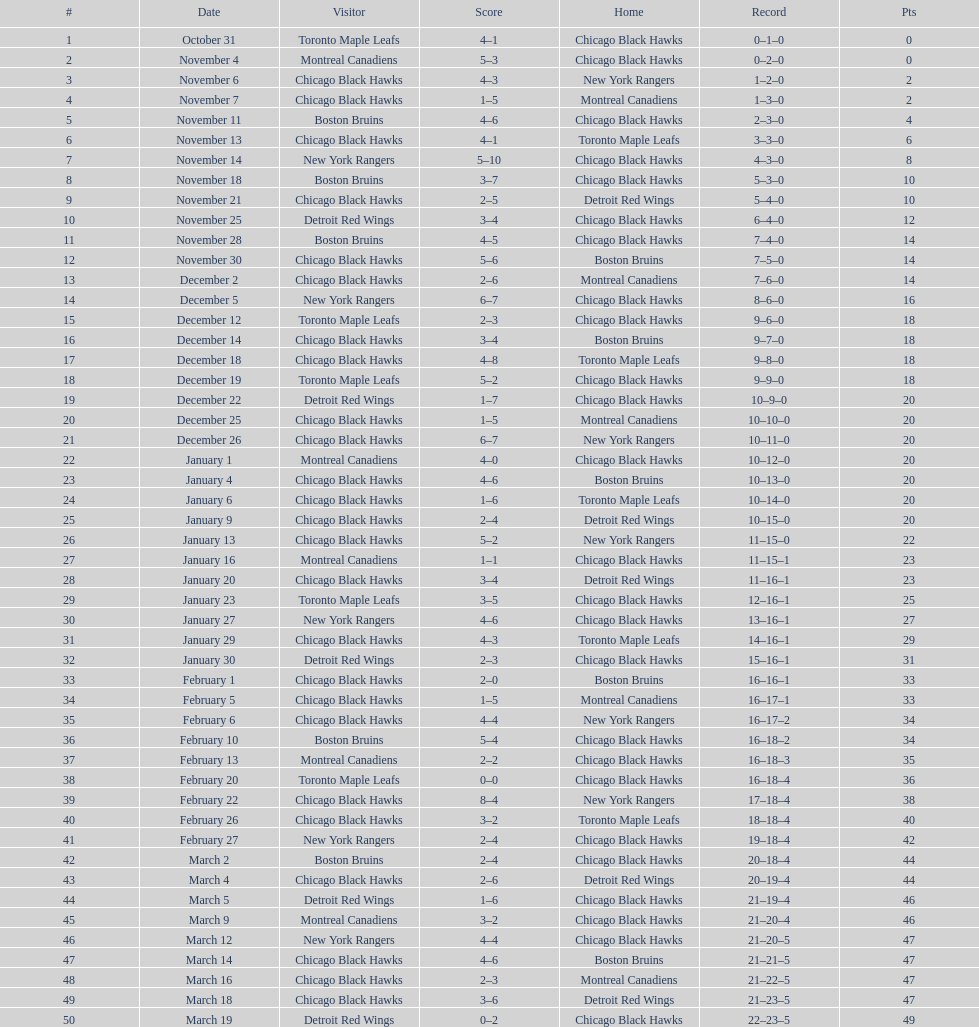How many total games did they win? 22. 